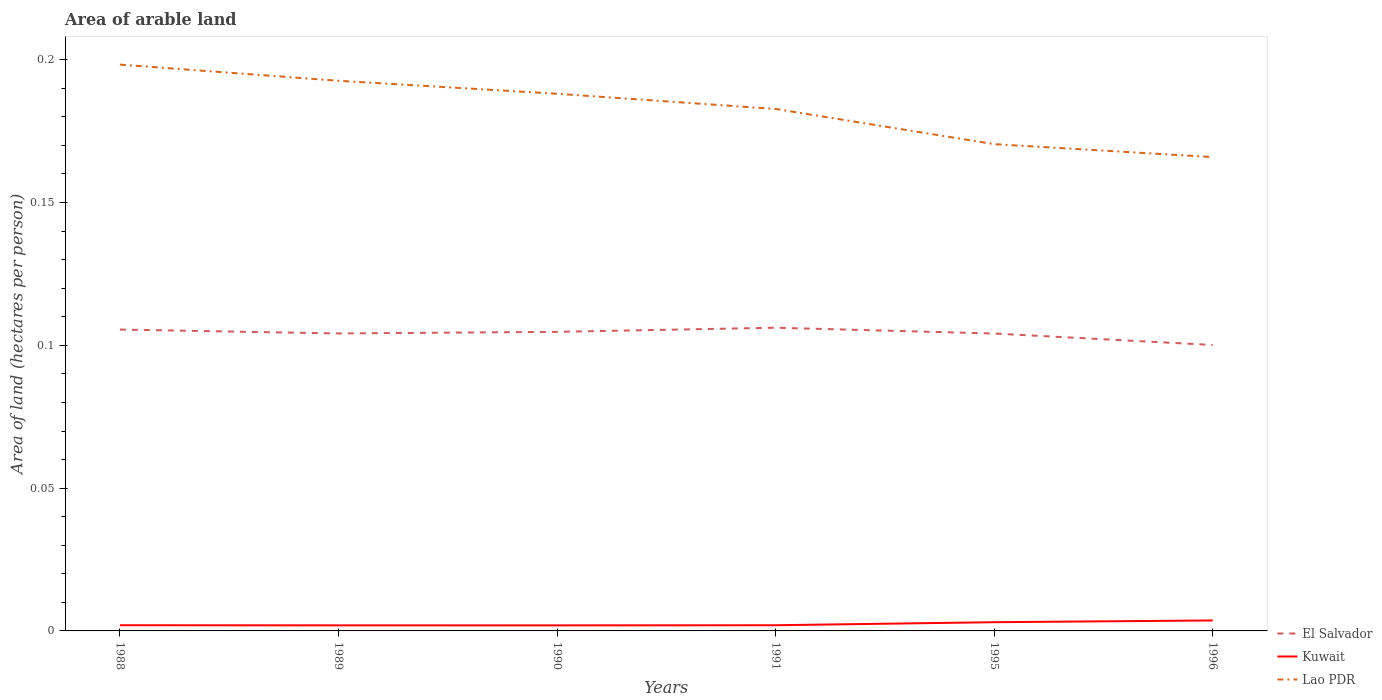How many different coloured lines are there?
Offer a very short reply. 3. Is the number of lines equal to the number of legend labels?
Offer a very short reply. Yes. Across all years, what is the maximum total arable land in Kuwait?
Give a very brief answer. 0. What is the total total arable land in Kuwait in the graph?
Your response must be concise. -0. What is the difference between the highest and the second highest total arable land in Kuwait?
Make the answer very short. 0. What is the difference between the highest and the lowest total arable land in Kuwait?
Keep it short and to the point. 2. How many lines are there?
Your answer should be compact. 3. Does the graph contain grids?
Your response must be concise. No. How are the legend labels stacked?
Offer a terse response. Vertical. What is the title of the graph?
Your answer should be compact. Area of arable land. Does "Marshall Islands" appear as one of the legend labels in the graph?
Your answer should be compact. No. What is the label or title of the X-axis?
Your answer should be compact. Years. What is the label or title of the Y-axis?
Offer a terse response. Area of land (hectares per person). What is the Area of land (hectares per person) of El Salvador in 1988?
Provide a succinct answer. 0.11. What is the Area of land (hectares per person) of Kuwait in 1988?
Give a very brief answer. 0. What is the Area of land (hectares per person) in Lao PDR in 1988?
Keep it short and to the point. 0.2. What is the Area of land (hectares per person) in El Salvador in 1989?
Give a very brief answer. 0.1. What is the Area of land (hectares per person) of Kuwait in 1989?
Give a very brief answer. 0. What is the Area of land (hectares per person) in Lao PDR in 1989?
Keep it short and to the point. 0.19. What is the Area of land (hectares per person) in El Salvador in 1990?
Your response must be concise. 0.1. What is the Area of land (hectares per person) in Kuwait in 1990?
Provide a succinct answer. 0. What is the Area of land (hectares per person) in Lao PDR in 1990?
Your response must be concise. 0.19. What is the Area of land (hectares per person) in El Salvador in 1991?
Your answer should be compact. 0.11. What is the Area of land (hectares per person) of Kuwait in 1991?
Provide a short and direct response. 0. What is the Area of land (hectares per person) of Lao PDR in 1991?
Provide a succinct answer. 0.18. What is the Area of land (hectares per person) in El Salvador in 1995?
Ensure brevity in your answer.  0.1. What is the Area of land (hectares per person) of Kuwait in 1995?
Your response must be concise. 0. What is the Area of land (hectares per person) in Lao PDR in 1995?
Your response must be concise. 0.17. What is the Area of land (hectares per person) in El Salvador in 1996?
Make the answer very short. 0.1. What is the Area of land (hectares per person) of Kuwait in 1996?
Offer a terse response. 0. What is the Area of land (hectares per person) of Lao PDR in 1996?
Offer a terse response. 0.17. Across all years, what is the maximum Area of land (hectares per person) in El Salvador?
Offer a very short reply. 0.11. Across all years, what is the maximum Area of land (hectares per person) in Kuwait?
Make the answer very short. 0. Across all years, what is the maximum Area of land (hectares per person) of Lao PDR?
Offer a terse response. 0.2. Across all years, what is the minimum Area of land (hectares per person) of El Salvador?
Ensure brevity in your answer.  0.1. Across all years, what is the minimum Area of land (hectares per person) of Kuwait?
Provide a short and direct response. 0. Across all years, what is the minimum Area of land (hectares per person) of Lao PDR?
Provide a short and direct response. 0.17. What is the total Area of land (hectares per person) of El Salvador in the graph?
Keep it short and to the point. 0.62. What is the total Area of land (hectares per person) of Kuwait in the graph?
Offer a very short reply. 0.01. What is the total Area of land (hectares per person) of Lao PDR in the graph?
Your answer should be compact. 1.1. What is the difference between the Area of land (hectares per person) of El Salvador in 1988 and that in 1989?
Provide a succinct answer. 0. What is the difference between the Area of land (hectares per person) of Lao PDR in 1988 and that in 1989?
Your response must be concise. 0.01. What is the difference between the Area of land (hectares per person) in El Salvador in 1988 and that in 1990?
Give a very brief answer. 0. What is the difference between the Area of land (hectares per person) in Kuwait in 1988 and that in 1990?
Keep it short and to the point. 0. What is the difference between the Area of land (hectares per person) of Lao PDR in 1988 and that in 1990?
Provide a succinct answer. 0.01. What is the difference between the Area of land (hectares per person) in El Salvador in 1988 and that in 1991?
Offer a terse response. -0. What is the difference between the Area of land (hectares per person) of Lao PDR in 1988 and that in 1991?
Keep it short and to the point. 0.02. What is the difference between the Area of land (hectares per person) in El Salvador in 1988 and that in 1995?
Make the answer very short. 0. What is the difference between the Area of land (hectares per person) of Kuwait in 1988 and that in 1995?
Provide a succinct answer. -0. What is the difference between the Area of land (hectares per person) in Lao PDR in 1988 and that in 1995?
Keep it short and to the point. 0.03. What is the difference between the Area of land (hectares per person) of El Salvador in 1988 and that in 1996?
Make the answer very short. 0.01. What is the difference between the Area of land (hectares per person) of Kuwait in 1988 and that in 1996?
Give a very brief answer. -0. What is the difference between the Area of land (hectares per person) in Lao PDR in 1988 and that in 1996?
Your response must be concise. 0.03. What is the difference between the Area of land (hectares per person) in El Salvador in 1989 and that in 1990?
Ensure brevity in your answer.  -0. What is the difference between the Area of land (hectares per person) of Lao PDR in 1989 and that in 1990?
Ensure brevity in your answer.  0. What is the difference between the Area of land (hectares per person) of El Salvador in 1989 and that in 1991?
Give a very brief answer. -0. What is the difference between the Area of land (hectares per person) of Lao PDR in 1989 and that in 1991?
Offer a very short reply. 0.01. What is the difference between the Area of land (hectares per person) in Kuwait in 1989 and that in 1995?
Make the answer very short. -0. What is the difference between the Area of land (hectares per person) of Lao PDR in 1989 and that in 1995?
Keep it short and to the point. 0.02. What is the difference between the Area of land (hectares per person) of El Salvador in 1989 and that in 1996?
Ensure brevity in your answer.  0. What is the difference between the Area of land (hectares per person) in Kuwait in 1989 and that in 1996?
Give a very brief answer. -0. What is the difference between the Area of land (hectares per person) of Lao PDR in 1989 and that in 1996?
Your answer should be very brief. 0.03. What is the difference between the Area of land (hectares per person) in El Salvador in 1990 and that in 1991?
Make the answer very short. -0. What is the difference between the Area of land (hectares per person) in Kuwait in 1990 and that in 1991?
Ensure brevity in your answer.  -0. What is the difference between the Area of land (hectares per person) of Lao PDR in 1990 and that in 1991?
Ensure brevity in your answer.  0.01. What is the difference between the Area of land (hectares per person) in El Salvador in 1990 and that in 1995?
Ensure brevity in your answer.  0. What is the difference between the Area of land (hectares per person) of Kuwait in 1990 and that in 1995?
Offer a terse response. -0. What is the difference between the Area of land (hectares per person) in Lao PDR in 1990 and that in 1995?
Provide a succinct answer. 0.02. What is the difference between the Area of land (hectares per person) of El Salvador in 1990 and that in 1996?
Your answer should be compact. 0. What is the difference between the Area of land (hectares per person) in Kuwait in 1990 and that in 1996?
Your response must be concise. -0. What is the difference between the Area of land (hectares per person) in Lao PDR in 1990 and that in 1996?
Your answer should be compact. 0.02. What is the difference between the Area of land (hectares per person) of El Salvador in 1991 and that in 1995?
Offer a terse response. 0. What is the difference between the Area of land (hectares per person) of Kuwait in 1991 and that in 1995?
Offer a terse response. -0. What is the difference between the Area of land (hectares per person) in Lao PDR in 1991 and that in 1995?
Your answer should be very brief. 0.01. What is the difference between the Area of land (hectares per person) in El Salvador in 1991 and that in 1996?
Provide a succinct answer. 0.01. What is the difference between the Area of land (hectares per person) in Kuwait in 1991 and that in 1996?
Ensure brevity in your answer.  -0. What is the difference between the Area of land (hectares per person) of Lao PDR in 1991 and that in 1996?
Your answer should be compact. 0.02. What is the difference between the Area of land (hectares per person) of El Salvador in 1995 and that in 1996?
Ensure brevity in your answer.  0. What is the difference between the Area of land (hectares per person) of Kuwait in 1995 and that in 1996?
Make the answer very short. -0. What is the difference between the Area of land (hectares per person) in Lao PDR in 1995 and that in 1996?
Your response must be concise. 0. What is the difference between the Area of land (hectares per person) in El Salvador in 1988 and the Area of land (hectares per person) in Kuwait in 1989?
Offer a terse response. 0.1. What is the difference between the Area of land (hectares per person) of El Salvador in 1988 and the Area of land (hectares per person) of Lao PDR in 1989?
Your answer should be compact. -0.09. What is the difference between the Area of land (hectares per person) in Kuwait in 1988 and the Area of land (hectares per person) in Lao PDR in 1989?
Your answer should be very brief. -0.19. What is the difference between the Area of land (hectares per person) in El Salvador in 1988 and the Area of land (hectares per person) in Kuwait in 1990?
Your answer should be very brief. 0.1. What is the difference between the Area of land (hectares per person) in El Salvador in 1988 and the Area of land (hectares per person) in Lao PDR in 1990?
Your answer should be very brief. -0.08. What is the difference between the Area of land (hectares per person) in Kuwait in 1988 and the Area of land (hectares per person) in Lao PDR in 1990?
Your answer should be very brief. -0.19. What is the difference between the Area of land (hectares per person) of El Salvador in 1988 and the Area of land (hectares per person) of Kuwait in 1991?
Your response must be concise. 0.1. What is the difference between the Area of land (hectares per person) of El Salvador in 1988 and the Area of land (hectares per person) of Lao PDR in 1991?
Keep it short and to the point. -0.08. What is the difference between the Area of land (hectares per person) of Kuwait in 1988 and the Area of land (hectares per person) of Lao PDR in 1991?
Make the answer very short. -0.18. What is the difference between the Area of land (hectares per person) of El Salvador in 1988 and the Area of land (hectares per person) of Kuwait in 1995?
Your answer should be compact. 0.1. What is the difference between the Area of land (hectares per person) of El Salvador in 1988 and the Area of land (hectares per person) of Lao PDR in 1995?
Offer a very short reply. -0.06. What is the difference between the Area of land (hectares per person) of Kuwait in 1988 and the Area of land (hectares per person) of Lao PDR in 1995?
Keep it short and to the point. -0.17. What is the difference between the Area of land (hectares per person) in El Salvador in 1988 and the Area of land (hectares per person) in Kuwait in 1996?
Offer a very short reply. 0.1. What is the difference between the Area of land (hectares per person) in El Salvador in 1988 and the Area of land (hectares per person) in Lao PDR in 1996?
Ensure brevity in your answer.  -0.06. What is the difference between the Area of land (hectares per person) in Kuwait in 1988 and the Area of land (hectares per person) in Lao PDR in 1996?
Your answer should be compact. -0.16. What is the difference between the Area of land (hectares per person) in El Salvador in 1989 and the Area of land (hectares per person) in Kuwait in 1990?
Keep it short and to the point. 0.1. What is the difference between the Area of land (hectares per person) of El Salvador in 1989 and the Area of land (hectares per person) of Lao PDR in 1990?
Offer a terse response. -0.08. What is the difference between the Area of land (hectares per person) in Kuwait in 1989 and the Area of land (hectares per person) in Lao PDR in 1990?
Keep it short and to the point. -0.19. What is the difference between the Area of land (hectares per person) of El Salvador in 1989 and the Area of land (hectares per person) of Kuwait in 1991?
Give a very brief answer. 0.1. What is the difference between the Area of land (hectares per person) of El Salvador in 1989 and the Area of land (hectares per person) of Lao PDR in 1991?
Your response must be concise. -0.08. What is the difference between the Area of land (hectares per person) of Kuwait in 1989 and the Area of land (hectares per person) of Lao PDR in 1991?
Your answer should be compact. -0.18. What is the difference between the Area of land (hectares per person) in El Salvador in 1989 and the Area of land (hectares per person) in Kuwait in 1995?
Your response must be concise. 0.1. What is the difference between the Area of land (hectares per person) of El Salvador in 1989 and the Area of land (hectares per person) of Lao PDR in 1995?
Provide a short and direct response. -0.07. What is the difference between the Area of land (hectares per person) of Kuwait in 1989 and the Area of land (hectares per person) of Lao PDR in 1995?
Make the answer very short. -0.17. What is the difference between the Area of land (hectares per person) of El Salvador in 1989 and the Area of land (hectares per person) of Kuwait in 1996?
Your response must be concise. 0.1. What is the difference between the Area of land (hectares per person) of El Salvador in 1989 and the Area of land (hectares per person) of Lao PDR in 1996?
Provide a succinct answer. -0.06. What is the difference between the Area of land (hectares per person) in Kuwait in 1989 and the Area of land (hectares per person) in Lao PDR in 1996?
Keep it short and to the point. -0.16. What is the difference between the Area of land (hectares per person) in El Salvador in 1990 and the Area of land (hectares per person) in Kuwait in 1991?
Your answer should be very brief. 0.1. What is the difference between the Area of land (hectares per person) of El Salvador in 1990 and the Area of land (hectares per person) of Lao PDR in 1991?
Give a very brief answer. -0.08. What is the difference between the Area of land (hectares per person) of Kuwait in 1990 and the Area of land (hectares per person) of Lao PDR in 1991?
Make the answer very short. -0.18. What is the difference between the Area of land (hectares per person) in El Salvador in 1990 and the Area of land (hectares per person) in Kuwait in 1995?
Provide a short and direct response. 0.1. What is the difference between the Area of land (hectares per person) of El Salvador in 1990 and the Area of land (hectares per person) of Lao PDR in 1995?
Provide a succinct answer. -0.07. What is the difference between the Area of land (hectares per person) of Kuwait in 1990 and the Area of land (hectares per person) of Lao PDR in 1995?
Your answer should be compact. -0.17. What is the difference between the Area of land (hectares per person) of El Salvador in 1990 and the Area of land (hectares per person) of Kuwait in 1996?
Your response must be concise. 0.1. What is the difference between the Area of land (hectares per person) in El Salvador in 1990 and the Area of land (hectares per person) in Lao PDR in 1996?
Keep it short and to the point. -0.06. What is the difference between the Area of land (hectares per person) in Kuwait in 1990 and the Area of land (hectares per person) in Lao PDR in 1996?
Give a very brief answer. -0.16. What is the difference between the Area of land (hectares per person) in El Salvador in 1991 and the Area of land (hectares per person) in Kuwait in 1995?
Your answer should be compact. 0.1. What is the difference between the Area of land (hectares per person) in El Salvador in 1991 and the Area of land (hectares per person) in Lao PDR in 1995?
Provide a short and direct response. -0.06. What is the difference between the Area of land (hectares per person) of Kuwait in 1991 and the Area of land (hectares per person) of Lao PDR in 1995?
Make the answer very short. -0.17. What is the difference between the Area of land (hectares per person) of El Salvador in 1991 and the Area of land (hectares per person) of Kuwait in 1996?
Your response must be concise. 0.1. What is the difference between the Area of land (hectares per person) in El Salvador in 1991 and the Area of land (hectares per person) in Lao PDR in 1996?
Give a very brief answer. -0.06. What is the difference between the Area of land (hectares per person) of Kuwait in 1991 and the Area of land (hectares per person) of Lao PDR in 1996?
Ensure brevity in your answer.  -0.16. What is the difference between the Area of land (hectares per person) in El Salvador in 1995 and the Area of land (hectares per person) in Kuwait in 1996?
Provide a short and direct response. 0.1. What is the difference between the Area of land (hectares per person) of El Salvador in 1995 and the Area of land (hectares per person) of Lao PDR in 1996?
Keep it short and to the point. -0.06. What is the difference between the Area of land (hectares per person) in Kuwait in 1995 and the Area of land (hectares per person) in Lao PDR in 1996?
Make the answer very short. -0.16. What is the average Area of land (hectares per person) of El Salvador per year?
Your response must be concise. 0.1. What is the average Area of land (hectares per person) in Kuwait per year?
Make the answer very short. 0. What is the average Area of land (hectares per person) of Lao PDR per year?
Ensure brevity in your answer.  0.18. In the year 1988, what is the difference between the Area of land (hectares per person) of El Salvador and Area of land (hectares per person) of Kuwait?
Offer a terse response. 0.1. In the year 1988, what is the difference between the Area of land (hectares per person) in El Salvador and Area of land (hectares per person) in Lao PDR?
Your answer should be very brief. -0.09. In the year 1988, what is the difference between the Area of land (hectares per person) in Kuwait and Area of land (hectares per person) in Lao PDR?
Provide a succinct answer. -0.2. In the year 1989, what is the difference between the Area of land (hectares per person) of El Salvador and Area of land (hectares per person) of Kuwait?
Provide a short and direct response. 0.1. In the year 1989, what is the difference between the Area of land (hectares per person) in El Salvador and Area of land (hectares per person) in Lao PDR?
Offer a terse response. -0.09. In the year 1989, what is the difference between the Area of land (hectares per person) in Kuwait and Area of land (hectares per person) in Lao PDR?
Provide a succinct answer. -0.19. In the year 1990, what is the difference between the Area of land (hectares per person) in El Salvador and Area of land (hectares per person) in Kuwait?
Give a very brief answer. 0.1. In the year 1990, what is the difference between the Area of land (hectares per person) in El Salvador and Area of land (hectares per person) in Lao PDR?
Your answer should be very brief. -0.08. In the year 1990, what is the difference between the Area of land (hectares per person) in Kuwait and Area of land (hectares per person) in Lao PDR?
Ensure brevity in your answer.  -0.19. In the year 1991, what is the difference between the Area of land (hectares per person) of El Salvador and Area of land (hectares per person) of Kuwait?
Make the answer very short. 0.1. In the year 1991, what is the difference between the Area of land (hectares per person) in El Salvador and Area of land (hectares per person) in Lao PDR?
Your answer should be compact. -0.08. In the year 1991, what is the difference between the Area of land (hectares per person) in Kuwait and Area of land (hectares per person) in Lao PDR?
Ensure brevity in your answer.  -0.18. In the year 1995, what is the difference between the Area of land (hectares per person) in El Salvador and Area of land (hectares per person) in Kuwait?
Offer a very short reply. 0.1. In the year 1995, what is the difference between the Area of land (hectares per person) of El Salvador and Area of land (hectares per person) of Lao PDR?
Provide a short and direct response. -0.07. In the year 1995, what is the difference between the Area of land (hectares per person) of Kuwait and Area of land (hectares per person) of Lao PDR?
Your answer should be very brief. -0.17. In the year 1996, what is the difference between the Area of land (hectares per person) of El Salvador and Area of land (hectares per person) of Kuwait?
Ensure brevity in your answer.  0.1. In the year 1996, what is the difference between the Area of land (hectares per person) in El Salvador and Area of land (hectares per person) in Lao PDR?
Offer a terse response. -0.07. In the year 1996, what is the difference between the Area of land (hectares per person) of Kuwait and Area of land (hectares per person) of Lao PDR?
Make the answer very short. -0.16. What is the ratio of the Area of land (hectares per person) in Kuwait in 1988 to that in 1989?
Keep it short and to the point. 1.03. What is the ratio of the Area of land (hectares per person) in Lao PDR in 1988 to that in 1989?
Your answer should be compact. 1.03. What is the ratio of the Area of land (hectares per person) of El Salvador in 1988 to that in 1990?
Offer a terse response. 1.01. What is the ratio of the Area of land (hectares per person) of Kuwait in 1988 to that in 1990?
Make the answer very short. 1.03. What is the ratio of the Area of land (hectares per person) of Lao PDR in 1988 to that in 1990?
Provide a short and direct response. 1.05. What is the ratio of the Area of land (hectares per person) in El Salvador in 1988 to that in 1991?
Your answer should be compact. 0.99. What is the ratio of the Area of land (hectares per person) of Lao PDR in 1988 to that in 1991?
Make the answer very short. 1.08. What is the ratio of the Area of land (hectares per person) of El Salvador in 1988 to that in 1995?
Your answer should be compact. 1.01. What is the ratio of the Area of land (hectares per person) of Kuwait in 1988 to that in 1995?
Offer a terse response. 0.65. What is the ratio of the Area of land (hectares per person) in Lao PDR in 1988 to that in 1995?
Ensure brevity in your answer.  1.16. What is the ratio of the Area of land (hectares per person) of El Salvador in 1988 to that in 1996?
Your answer should be very brief. 1.05. What is the ratio of the Area of land (hectares per person) in Kuwait in 1988 to that in 1996?
Provide a succinct answer. 0.55. What is the ratio of the Area of land (hectares per person) of Lao PDR in 1988 to that in 1996?
Provide a short and direct response. 1.2. What is the ratio of the Area of land (hectares per person) in El Salvador in 1989 to that in 1990?
Keep it short and to the point. 0.99. What is the ratio of the Area of land (hectares per person) in Kuwait in 1989 to that in 1990?
Provide a short and direct response. 1. What is the ratio of the Area of land (hectares per person) in Lao PDR in 1989 to that in 1990?
Offer a terse response. 1.02. What is the ratio of the Area of land (hectares per person) of El Salvador in 1989 to that in 1991?
Offer a very short reply. 0.98. What is the ratio of the Area of land (hectares per person) of Kuwait in 1989 to that in 1991?
Your response must be concise. 0.98. What is the ratio of the Area of land (hectares per person) of Lao PDR in 1989 to that in 1991?
Ensure brevity in your answer.  1.05. What is the ratio of the Area of land (hectares per person) of El Salvador in 1989 to that in 1995?
Provide a short and direct response. 1. What is the ratio of the Area of land (hectares per person) in Kuwait in 1989 to that in 1995?
Keep it short and to the point. 0.64. What is the ratio of the Area of land (hectares per person) of Lao PDR in 1989 to that in 1995?
Offer a terse response. 1.13. What is the ratio of the Area of land (hectares per person) in El Salvador in 1989 to that in 1996?
Provide a succinct answer. 1.04. What is the ratio of the Area of land (hectares per person) of Kuwait in 1989 to that in 1996?
Provide a succinct answer. 0.53. What is the ratio of the Area of land (hectares per person) of Lao PDR in 1989 to that in 1996?
Provide a succinct answer. 1.16. What is the ratio of the Area of land (hectares per person) in El Salvador in 1990 to that in 1991?
Give a very brief answer. 0.99. What is the ratio of the Area of land (hectares per person) of Kuwait in 1990 to that in 1991?
Your answer should be compact. 0.97. What is the ratio of the Area of land (hectares per person) of Lao PDR in 1990 to that in 1991?
Provide a succinct answer. 1.03. What is the ratio of the Area of land (hectares per person) in El Salvador in 1990 to that in 1995?
Keep it short and to the point. 1.01. What is the ratio of the Area of land (hectares per person) in Kuwait in 1990 to that in 1995?
Provide a succinct answer. 0.64. What is the ratio of the Area of land (hectares per person) in Lao PDR in 1990 to that in 1995?
Keep it short and to the point. 1.1. What is the ratio of the Area of land (hectares per person) in El Salvador in 1990 to that in 1996?
Offer a very short reply. 1.05. What is the ratio of the Area of land (hectares per person) of Kuwait in 1990 to that in 1996?
Make the answer very short. 0.53. What is the ratio of the Area of land (hectares per person) in Lao PDR in 1990 to that in 1996?
Keep it short and to the point. 1.13. What is the ratio of the Area of land (hectares per person) of El Salvador in 1991 to that in 1995?
Provide a short and direct response. 1.02. What is the ratio of the Area of land (hectares per person) of Kuwait in 1991 to that in 1995?
Ensure brevity in your answer.  0.65. What is the ratio of the Area of land (hectares per person) in Lao PDR in 1991 to that in 1995?
Your answer should be compact. 1.07. What is the ratio of the Area of land (hectares per person) in El Salvador in 1991 to that in 1996?
Your answer should be very brief. 1.06. What is the ratio of the Area of land (hectares per person) in Kuwait in 1991 to that in 1996?
Provide a succinct answer. 0.54. What is the ratio of the Area of land (hectares per person) in Lao PDR in 1991 to that in 1996?
Your answer should be very brief. 1.1. What is the ratio of the Area of land (hectares per person) of El Salvador in 1995 to that in 1996?
Keep it short and to the point. 1.04. What is the ratio of the Area of land (hectares per person) in Kuwait in 1995 to that in 1996?
Provide a short and direct response. 0.83. What is the ratio of the Area of land (hectares per person) of Lao PDR in 1995 to that in 1996?
Offer a very short reply. 1.03. What is the difference between the highest and the second highest Area of land (hectares per person) of El Salvador?
Your answer should be very brief. 0. What is the difference between the highest and the second highest Area of land (hectares per person) of Kuwait?
Offer a terse response. 0. What is the difference between the highest and the second highest Area of land (hectares per person) of Lao PDR?
Make the answer very short. 0.01. What is the difference between the highest and the lowest Area of land (hectares per person) of El Salvador?
Ensure brevity in your answer.  0.01. What is the difference between the highest and the lowest Area of land (hectares per person) in Kuwait?
Your answer should be compact. 0. What is the difference between the highest and the lowest Area of land (hectares per person) in Lao PDR?
Keep it short and to the point. 0.03. 